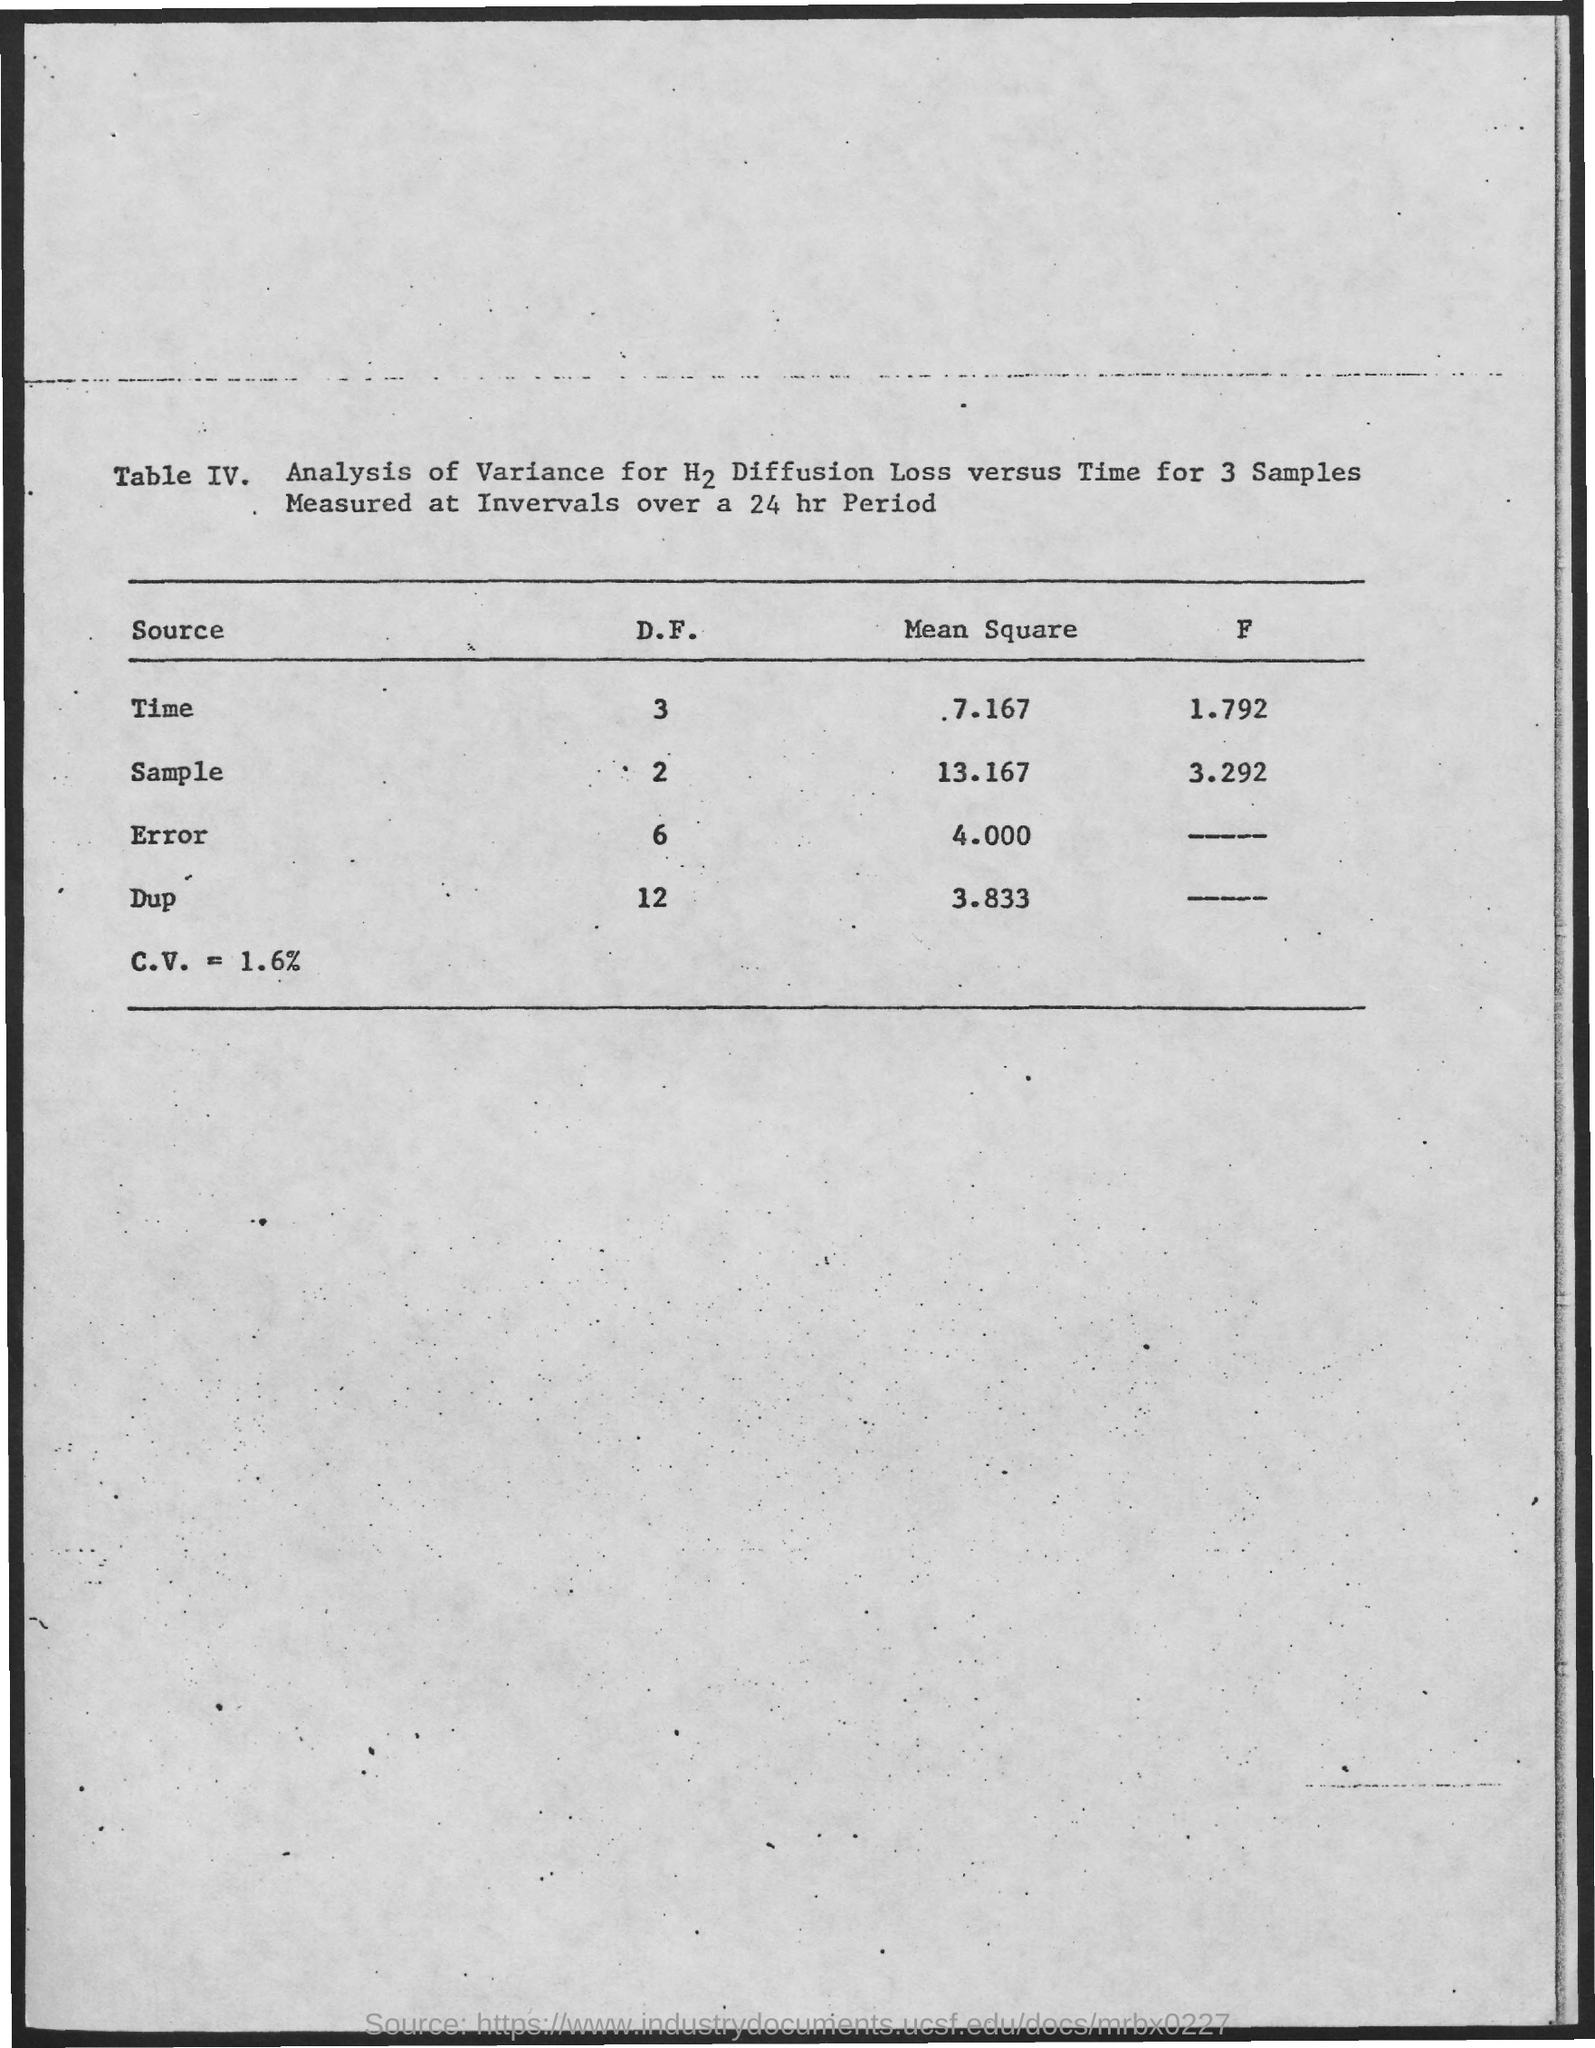What is the Mean Square for time?
Make the answer very short. 7.167. What is the Mean Square for Sample?
Provide a short and direct response. 13.167. What is the Mean Square for Error?
Your response must be concise. 4.000. What is the Mean Square for Dup?
Give a very brief answer. 3.833. 